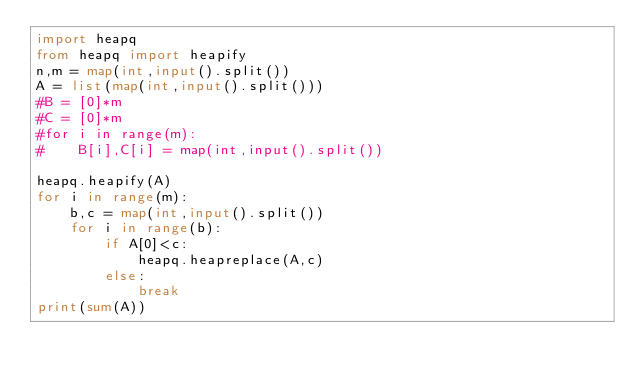Convert code to text. <code><loc_0><loc_0><loc_500><loc_500><_Python_>import heapq
from heapq import heapify
n,m = map(int,input().split())
A = list(map(int,input().split()))
#B = [0]*m
#C = [0]*m
#for i in range(m):
#    B[i],C[i] = map(int,input().split())

heapq.heapify(A)
for i in range(m):
    b,c = map(int,input().split())
    for i in range(b):
        if A[0]<c:
            heapq.heapreplace(A,c)
        else:
            break
print(sum(A))
</code> 